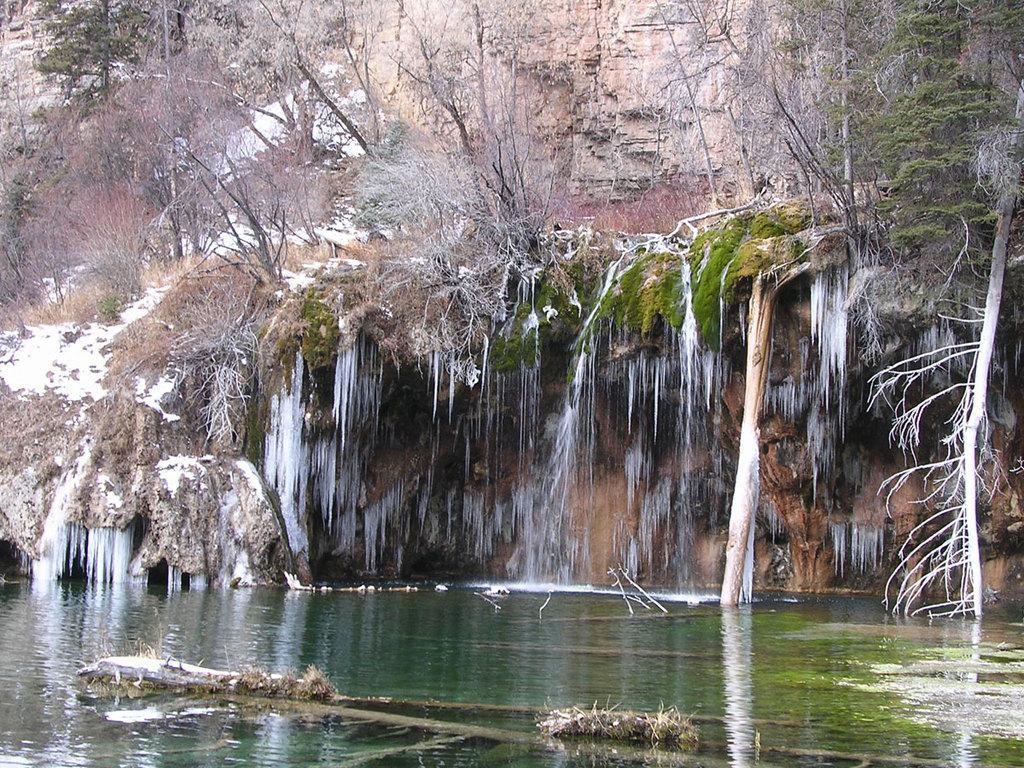In one or two sentences, can you explain what this image depicts? There are some trees on a mountain at the top of this image, and there is a water at the bottom of this image. 